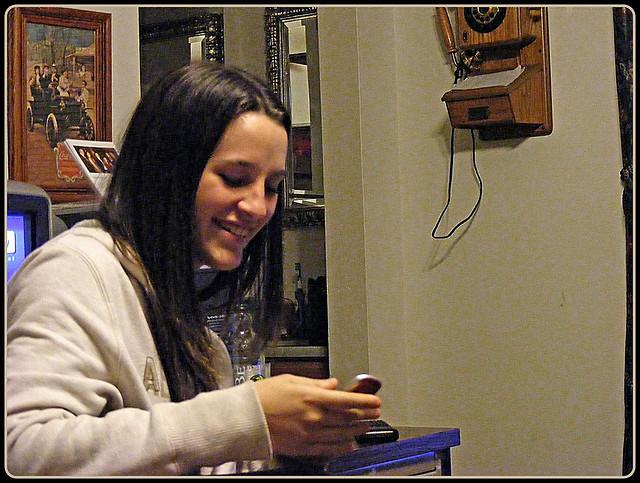What is in the lady's hand?
Keep it brief. Phone. What direction is the lady looking?
Answer briefly. Down. Is there a car in the picture behind the lady?
Give a very brief answer. Yes. 